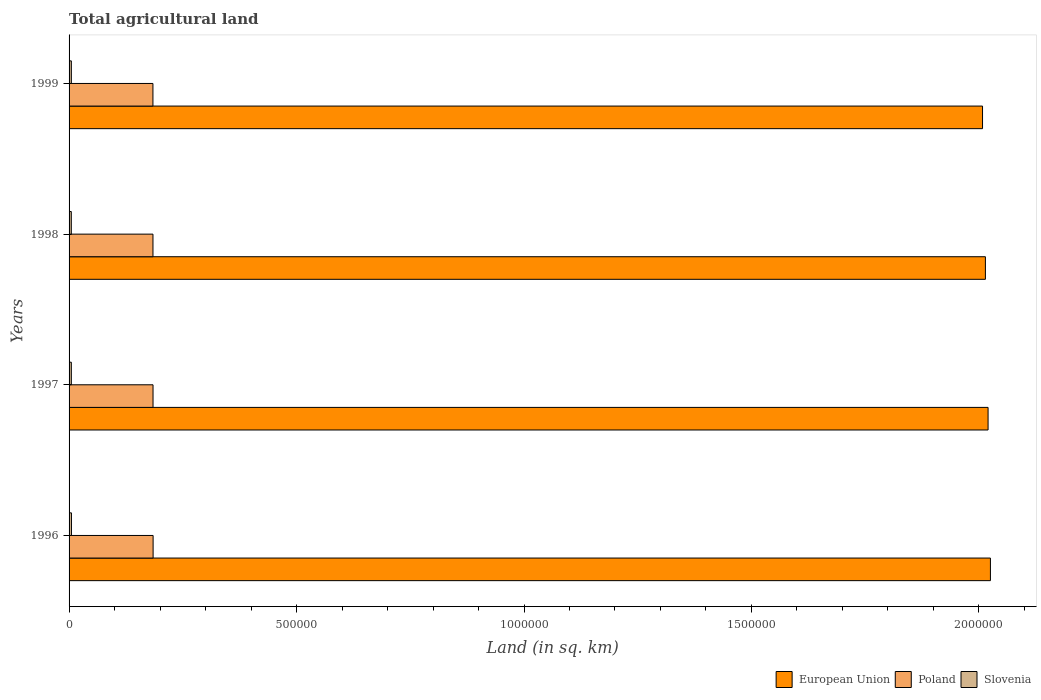How many groups of bars are there?
Keep it short and to the point. 4. Are the number of bars per tick equal to the number of legend labels?
Keep it short and to the point. Yes. How many bars are there on the 2nd tick from the top?
Your answer should be very brief. 3. What is the label of the 4th group of bars from the top?
Your response must be concise. 1996. In how many cases, is the number of bars for a given year not equal to the number of legend labels?
Offer a terse response. 0. What is the total agricultural land in European Union in 1999?
Your response must be concise. 2.01e+06. Across all years, what is the maximum total agricultural land in Slovenia?
Ensure brevity in your answer.  5250. Across all years, what is the minimum total agricultural land in Slovenia?
Make the answer very short. 4900. In which year was the total agricultural land in Slovenia maximum?
Make the answer very short. 1996. What is the total total agricultural land in Poland in the graph?
Make the answer very short. 7.38e+05. What is the difference between the total agricultural land in Slovenia in 1997 and that in 1998?
Ensure brevity in your answer.  50. What is the difference between the total agricultural land in European Union in 1996 and the total agricultural land in Poland in 1999?
Provide a short and direct response. 1.84e+06. What is the average total agricultural land in European Union per year?
Your response must be concise. 2.02e+06. In the year 1999, what is the difference between the total agricultural land in European Union and total agricultural land in Slovenia?
Offer a terse response. 2.00e+06. In how many years, is the total agricultural land in Slovenia greater than 400000 sq.km?
Provide a short and direct response. 0. What is the ratio of the total agricultural land in Slovenia in 1996 to that in 1997?
Provide a short and direct response. 1.06. Is the total agricultural land in Slovenia in 1996 less than that in 1997?
Your answer should be compact. No. Is the difference between the total agricultural land in European Union in 1997 and 1999 greater than the difference between the total agricultural land in Slovenia in 1997 and 1999?
Ensure brevity in your answer.  Yes. What is the difference between the highest and the second highest total agricultural land in Poland?
Offer a terse response. 170. What is the difference between the highest and the lowest total agricultural land in Poland?
Offer a terse response. 390. In how many years, is the total agricultural land in European Union greater than the average total agricultural land in European Union taken over all years?
Give a very brief answer. 2. Is the sum of the total agricultural land in Slovenia in 1997 and 1999 greater than the maximum total agricultural land in Poland across all years?
Provide a succinct answer. No. What does the 3rd bar from the top in 1998 represents?
Your response must be concise. European Union. How many bars are there?
Your response must be concise. 12. Does the graph contain any zero values?
Ensure brevity in your answer.  No. How many legend labels are there?
Your answer should be compact. 3. What is the title of the graph?
Ensure brevity in your answer.  Total agricultural land. Does "Caribbean small states" appear as one of the legend labels in the graph?
Offer a terse response. No. What is the label or title of the X-axis?
Your response must be concise. Land (in sq. km). What is the Land (in sq. km) in European Union in 1996?
Your answer should be compact. 2.03e+06. What is the Land (in sq. km) in Poland in 1996?
Your response must be concise. 1.85e+05. What is the Land (in sq. km) in Slovenia in 1996?
Your answer should be compact. 5250. What is the Land (in sq. km) of European Union in 1997?
Offer a terse response. 2.02e+06. What is the Land (in sq. km) of Poland in 1997?
Give a very brief answer. 1.85e+05. What is the Land (in sq. km) in Slovenia in 1997?
Keep it short and to the point. 4950. What is the Land (in sq. km) of European Union in 1998?
Provide a succinct answer. 2.01e+06. What is the Land (in sq. km) in Poland in 1998?
Keep it short and to the point. 1.84e+05. What is the Land (in sq. km) of Slovenia in 1998?
Provide a short and direct response. 4900. What is the Land (in sq. km) of European Union in 1999?
Offer a very short reply. 2.01e+06. What is the Land (in sq. km) in Poland in 1999?
Give a very brief answer. 1.84e+05. Across all years, what is the maximum Land (in sq. km) of European Union?
Offer a terse response. 2.03e+06. Across all years, what is the maximum Land (in sq. km) in Poland?
Keep it short and to the point. 1.85e+05. Across all years, what is the maximum Land (in sq. km) in Slovenia?
Your answer should be very brief. 5250. Across all years, what is the minimum Land (in sq. km) of European Union?
Your answer should be compact. 2.01e+06. Across all years, what is the minimum Land (in sq. km) of Poland?
Provide a succinct answer. 1.84e+05. Across all years, what is the minimum Land (in sq. km) in Slovenia?
Keep it short and to the point. 4900. What is the total Land (in sq. km) of European Union in the graph?
Your response must be concise. 8.07e+06. What is the total Land (in sq. km) of Poland in the graph?
Offer a very short reply. 7.38e+05. What is the total Land (in sq. km) in Slovenia in the graph?
Give a very brief answer. 2.01e+04. What is the difference between the Land (in sq. km) in European Union in 1996 and that in 1997?
Provide a succinct answer. 5167. What is the difference between the Land (in sq. km) in Poland in 1996 and that in 1997?
Provide a succinct answer. 170. What is the difference between the Land (in sq. km) of Slovenia in 1996 and that in 1997?
Your answer should be very brief. 300. What is the difference between the Land (in sq. km) of European Union in 1996 and that in 1998?
Your answer should be compact. 1.10e+04. What is the difference between the Land (in sq. km) of Poland in 1996 and that in 1998?
Provide a succinct answer. 310. What is the difference between the Land (in sq. km) of Slovenia in 1996 and that in 1998?
Provide a succinct answer. 350. What is the difference between the Land (in sq. km) in European Union in 1996 and that in 1999?
Make the answer very short. 1.73e+04. What is the difference between the Land (in sq. km) in Poland in 1996 and that in 1999?
Your response must be concise. 390. What is the difference between the Land (in sq. km) in Slovenia in 1996 and that in 1999?
Your answer should be very brief. 250. What is the difference between the Land (in sq. km) of European Union in 1997 and that in 1998?
Your answer should be compact. 5856. What is the difference between the Land (in sq. km) in Poland in 1997 and that in 1998?
Ensure brevity in your answer.  140. What is the difference between the Land (in sq. km) in European Union in 1997 and that in 1999?
Offer a terse response. 1.22e+04. What is the difference between the Land (in sq. km) in Poland in 1997 and that in 1999?
Your response must be concise. 220. What is the difference between the Land (in sq. km) in Slovenia in 1997 and that in 1999?
Offer a terse response. -50. What is the difference between the Land (in sq. km) of European Union in 1998 and that in 1999?
Provide a short and direct response. 6325. What is the difference between the Land (in sq. km) of Slovenia in 1998 and that in 1999?
Ensure brevity in your answer.  -100. What is the difference between the Land (in sq. km) in European Union in 1996 and the Land (in sq. km) in Poland in 1997?
Keep it short and to the point. 1.84e+06. What is the difference between the Land (in sq. km) in European Union in 1996 and the Land (in sq. km) in Slovenia in 1997?
Ensure brevity in your answer.  2.02e+06. What is the difference between the Land (in sq. km) of Poland in 1996 and the Land (in sq. km) of Slovenia in 1997?
Provide a succinct answer. 1.80e+05. What is the difference between the Land (in sq. km) in European Union in 1996 and the Land (in sq. km) in Poland in 1998?
Provide a succinct answer. 1.84e+06. What is the difference between the Land (in sq. km) in European Union in 1996 and the Land (in sq. km) in Slovenia in 1998?
Provide a succinct answer. 2.02e+06. What is the difference between the Land (in sq. km) in Poland in 1996 and the Land (in sq. km) in Slovenia in 1998?
Your answer should be very brief. 1.80e+05. What is the difference between the Land (in sq. km) of European Union in 1996 and the Land (in sq. km) of Poland in 1999?
Provide a short and direct response. 1.84e+06. What is the difference between the Land (in sq. km) of European Union in 1996 and the Land (in sq. km) of Slovenia in 1999?
Your response must be concise. 2.02e+06. What is the difference between the Land (in sq. km) of Poland in 1996 and the Land (in sq. km) of Slovenia in 1999?
Provide a short and direct response. 1.80e+05. What is the difference between the Land (in sq. km) of European Union in 1997 and the Land (in sq. km) of Poland in 1998?
Provide a succinct answer. 1.84e+06. What is the difference between the Land (in sq. km) of European Union in 1997 and the Land (in sq. km) of Slovenia in 1998?
Offer a terse response. 2.02e+06. What is the difference between the Land (in sq. km) of Poland in 1997 and the Land (in sq. km) of Slovenia in 1998?
Provide a succinct answer. 1.80e+05. What is the difference between the Land (in sq. km) in European Union in 1997 and the Land (in sq. km) in Poland in 1999?
Provide a succinct answer. 1.84e+06. What is the difference between the Land (in sq. km) in European Union in 1997 and the Land (in sq. km) in Slovenia in 1999?
Make the answer very short. 2.02e+06. What is the difference between the Land (in sq. km) in Poland in 1997 and the Land (in sq. km) in Slovenia in 1999?
Provide a succinct answer. 1.80e+05. What is the difference between the Land (in sq. km) of European Union in 1998 and the Land (in sq. km) of Poland in 1999?
Your response must be concise. 1.83e+06. What is the difference between the Land (in sq. km) of European Union in 1998 and the Land (in sq. km) of Slovenia in 1999?
Your answer should be very brief. 2.01e+06. What is the difference between the Land (in sq. km) in Poland in 1998 and the Land (in sq. km) in Slovenia in 1999?
Give a very brief answer. 1.79e+05. What is the average Land (in sq. km) of European Union per year?
Offer a terse response. 2.02e+06. What is the average Land (in sq. km) of Poland per year?
Keep it short and to the point. 1.85e+05. What is the average Land (in sq. km) of Slovenia per year?
Ensure brevity in your answer.  5025. In the year 1996, what is the difference between the Land (in sq. km) in European Union and Land (in sq. km) in Poland?
Keep it short and to the point. 1.84e+06. In the year 1996, what is the difference between the Land (in sq. km) of European Union and Land (in sq. km) of Slovenia?
Offer a terse response. 2.02e+06. In the year 1996, what is the difference between the Land (in sq. km) of Poland and Land (in sq. km) of Slovenia?
Your answer should be compact. 1.79e+05. In the year 1997, what is the difference between the Land (in sq. km) of European Union and Land (in sq. km) of Poland?
Your answer should be compact. 1.84e+06. In the year 1997, what is the difference between the Land (in sq. km) in European Union and Land (in sq. km) in Slovenia?
Offer a very short reply. 2.02e+06. In the year 1997, what is the difference between the Land (in sq. km) in Poland and Land (in sq. km) in Slovenia?
Provide a succinct answer. 1.80e+05. In the year 1998, what is the difference between the Land (in sq. km) of European Union and Land (in sq. km) of Poland?
Make the answer very short. 1.83e+06. In the year 1998, what is the difference between the Land (in sq. km) in European Union and Land (in sq. km) in Slovenia?
Your answer should be compact. 2.01e+06. In the year 1998, what is the difference between the Land (in sq. km) in Poland and Land (in sq. km) in Slovenia?
Your answer should be compact. 1.80e+05. In the year 1999, what is the difference between the Land (in sq. km) of European Union and Land (in sq. km) of Poland?
Provide a short and direct response. 1.82e+06. In the year 1999, what is the difference between the Land (in sq. km) of European Union and Land (in sq. km) of Slovenia?
Provide a succinct answer. 2.00e+06. In the year 1999, what is the difference between the Land (in sq. km) of Poland and Land (in sq. km) of Slovenia?
Ensure brevity in your answer.  1.79e+05. What is the ratio of the Land (in sq. km) in Poland in 1996 to that in 1997?
Keep it short and to the point. 1. What is the ratio of the Land (in sq. km) of Slovenia in 1996 to that in 1997?
Ensure brevity in your answer.  1.06. What is the ratio of the Land (in sq. km) of European Union in 1996 to that in 1998?
Your response must be concise. 1.01. What is the ratio of the Land (in sq. km) in Poland in 1996 to that in 1998?
Keep it short and to the point. 1. What is the ratio of the Land (in sq. km) in Slovenia in 1996 to that in 1998?
Keep it short and to the point. 1.07. What is the ratio of the Land (in sq. km) of European Union in 1996 to that in 1999?
Keep it short and to the point. 1.01. What is the ratio of the Land (in sq. km) of Poland in 1996 to that in 1999?
Offer a very short reply. 1. What is the ratio of the Land (in sq. km) in Slovenia in 1996 to that in 1999?
Ensure brevity in your answer.  1.05. What is the ratio of the Land (in sq. km) in European Union in 1997 to that in 1998?
Offer a terse response. 1. What is the ratio of the Land (in sq. km) of Slovenia in 1997 to that in 1998?
Provide a succinct answer. 1.01. What is the ratio of the Land (in sq. km) in European Union in 1997 to that in 1999?
Provide a succinct answer. 1.01. What is the ratio of the Land (in sq. km) of Poland in 1997 to that in 1999?
Provide a short and direct response. 1. What is the ratio of the Land (in sq. km) of Poland in 1998 to that in 1999?
Keep it short and to the point. 1. What is the difference between the highest and the second highest Land (in sq. km) of European Union?
Your answer should be very brief. 5167. What is the difference between the highest and the second highest Land (in sq. km) in Poland?
Keep it short and to the point. 170. What is the difference between the highest and the second highest Land (in sq. km) of Slovenia?
Keep it short and to the point. 250. What is the difference between the highest and the lowest Land (in sq. km) in European Union?
Offer a terse response. 1.73e+04. What is the difference between the highest and the lowest Land (in sq. km) of Poland?
Your answer should be compact. 390. What is the difference between the highest and the lowest Land (in sq. km) in Slovenia?
Your answer should be very brief. 350. 